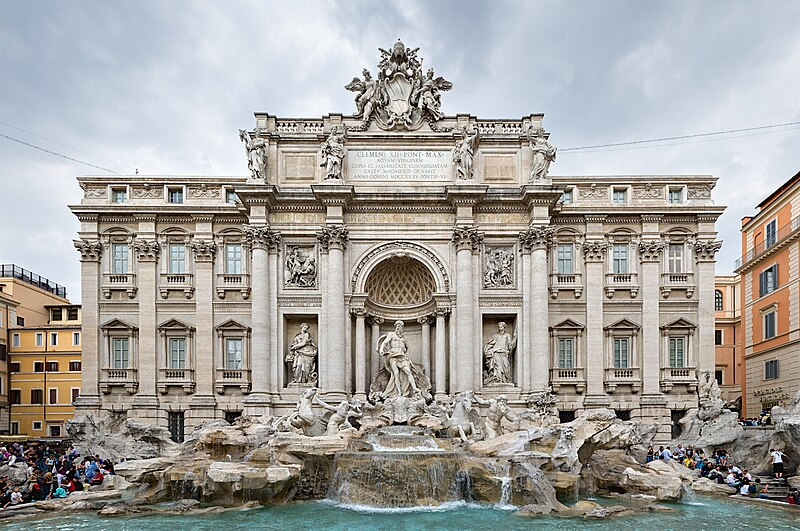Imagine the story behind the characters sculpted on the Trevi Fountain. In the heart of Rome, the Trevi Fountain comes alive at night when the statues secretly animate under the moonlight. Oceanus, the formidable god of the sea, commands the waters to part before him, while the Tritons playfully race through the cascading streams. The horses, emboldened by their master's call, gallop through time, each stride a ripple in history. As dawn approaches, the figures return to their solemn states, their mystical dance hidden once again from human eyes, embodying the eternal spirit of Rome and its guardians. What practical and historical significance does the Trevi Fountain hold? Historically, the Trevi Fountain has significant importance as it marks the end of the Aqua Virgo, an ancient Roman aqueduct constructed in 19 BC that provided water to the Baths of Agrippa and later, the fountains of Rome. Its practical role was to serve as a source of fresh drinking water, demonstrating Roman engineering excellence. Over the centuries, it also became a symbol of Rome’s artistic ingenuity and cultural resurgence during the Renaissance and Baroque periods. Today, it stands as a monument of both functional and aesthetic achievement, continually drawing admiration from all who visit. 